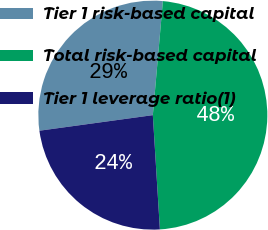Convert chart. <chart><loc_0><loc_0><loc_500><loc_500><pie_chart><fcel>Tier 1 risk-based capital<fcel>Total risk-based capital<fcel>Tier 1 leverage ratio(1)<nl><fcel>28.57%<fcel>47.62%<fcel>23.81%<nl></chart> 